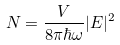Convert formula to latex. <formula><loc_0><loc_0><loc_500><loc_500>N = \frac { V } { 8 \pi \hbar { \omega } } | E | ^ { 2 }</formula> 